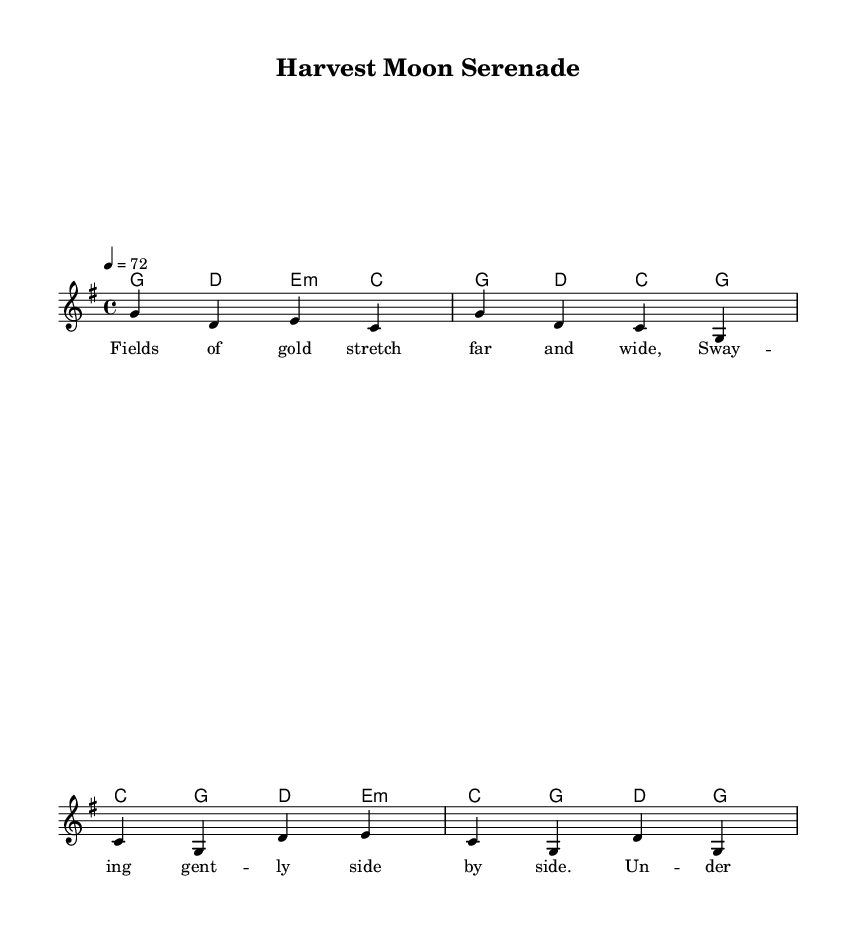What is the key signature of this music? The key signature shown is G major, which has one sharp (F#). This is indicated at the beginning of the sheet music where the key signature appears.
Answer: G major What is the time signature of this music? The time signature present is 4/4, meaning there are four beats in each measure and a quarter note receives one beat. This is displayed at the beginning of the score, before the notes begin.
Answer: 4/4 What is the tempo marking for this music? The tempo marking is indicated as 4 = 72, which means there are 72 beats per minute. This is typically featured at the top of the sheet music near the key and time signature.
Answer: 72 How many measures are in the verse? There are 4 measures in the verse section as evidenced by the musical notation that contains four distinct groupings for the melody and harmonies.
Answer: 4 What type of song is "Harvest Moon Serenade"? The song is categorized as a country ballad, specifically celebrating rural life and agricultural communities, reflected in its lyrics and overall thematic elements. This can be inferred from the title and content of the lyrics.
Answer: Country ballad What instrument is primarily featured in this sheet music? The primary instrument indicated in the score is a staff for the lead voice, typically representing a vocal part, as denoted by the title "lead" under the defined voice.
Answer: Voice What is the main theme of the chorus lyrics? The main theme of the chorus lyrics celebrates farming life, specifically emphasizing joyful moments under the harvest moon, as seen in the lyrical content itself.
Answer: Celebrating farming life 